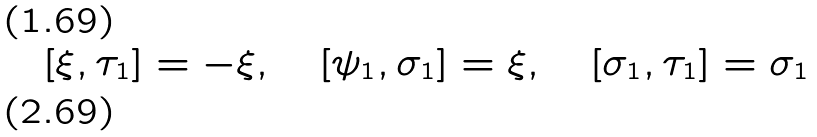Convert formula to latex. <formula><loc_0><loc_0><loc_500><loc_500>[ \xi , \tau _ { 1 } ] = - \xi , \quad [ \psi _ { 1 } , \sigma _ { 1 } ] = \xi , \quad [ \sigma _ { 1 } , \tau _ { 1 } ] = \sigma _ { 1 } \\</formula> 